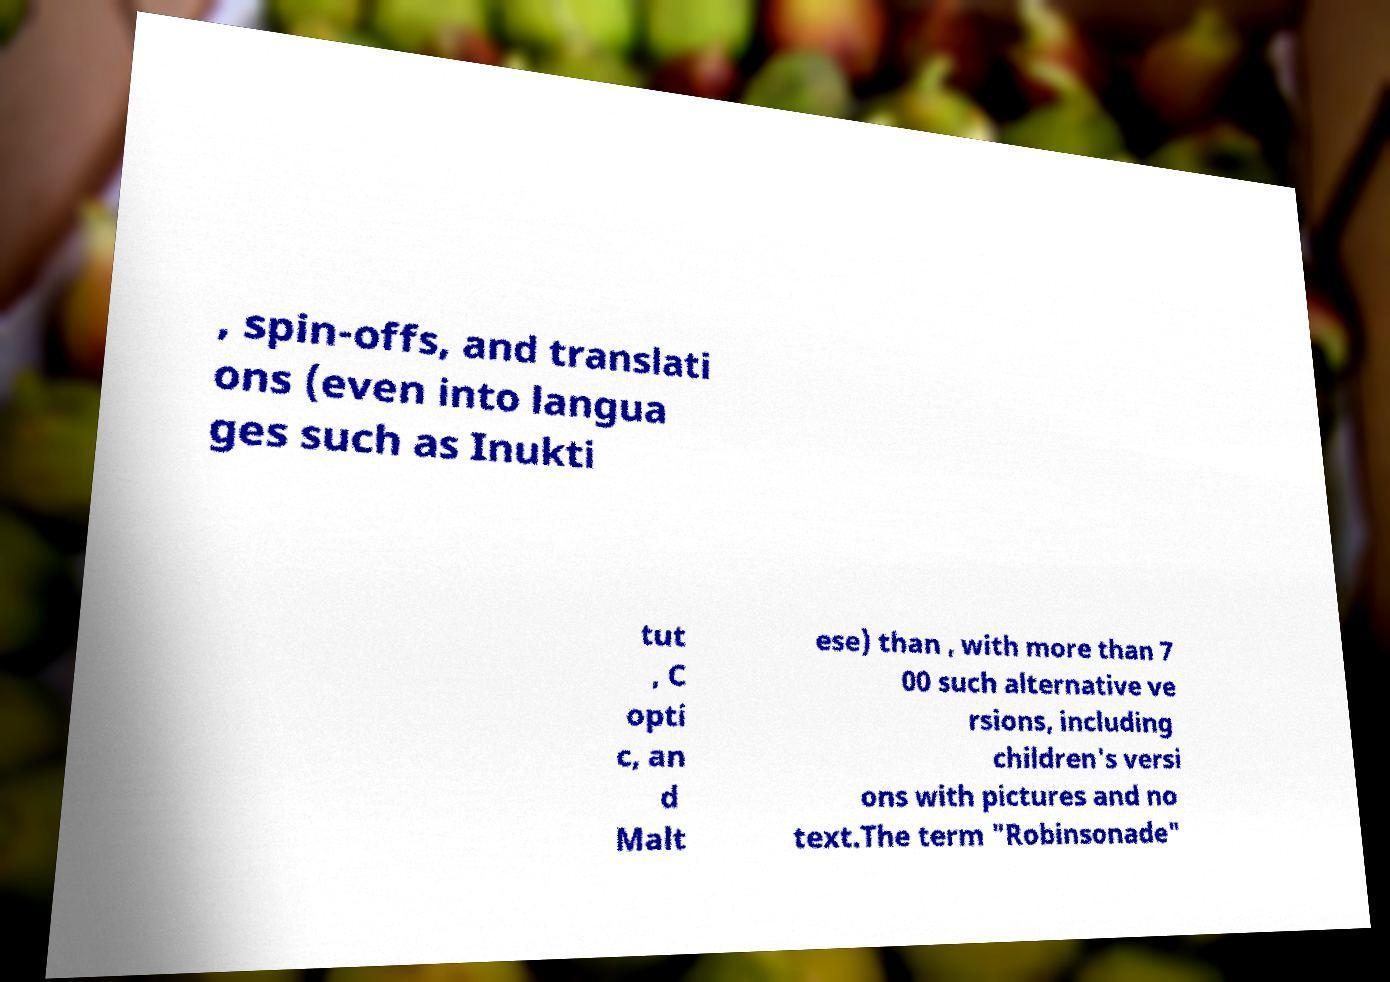I need the written content from this picture converted into text. Can you do that? , spin-offs, and translati ons (even into langua ges such as Inukti tut , C opti c, an d Malt ese) than , with more than 7 00 such alternative ve rsions, including children's versi ons with pictures and no text.The term "Robinsonade" 